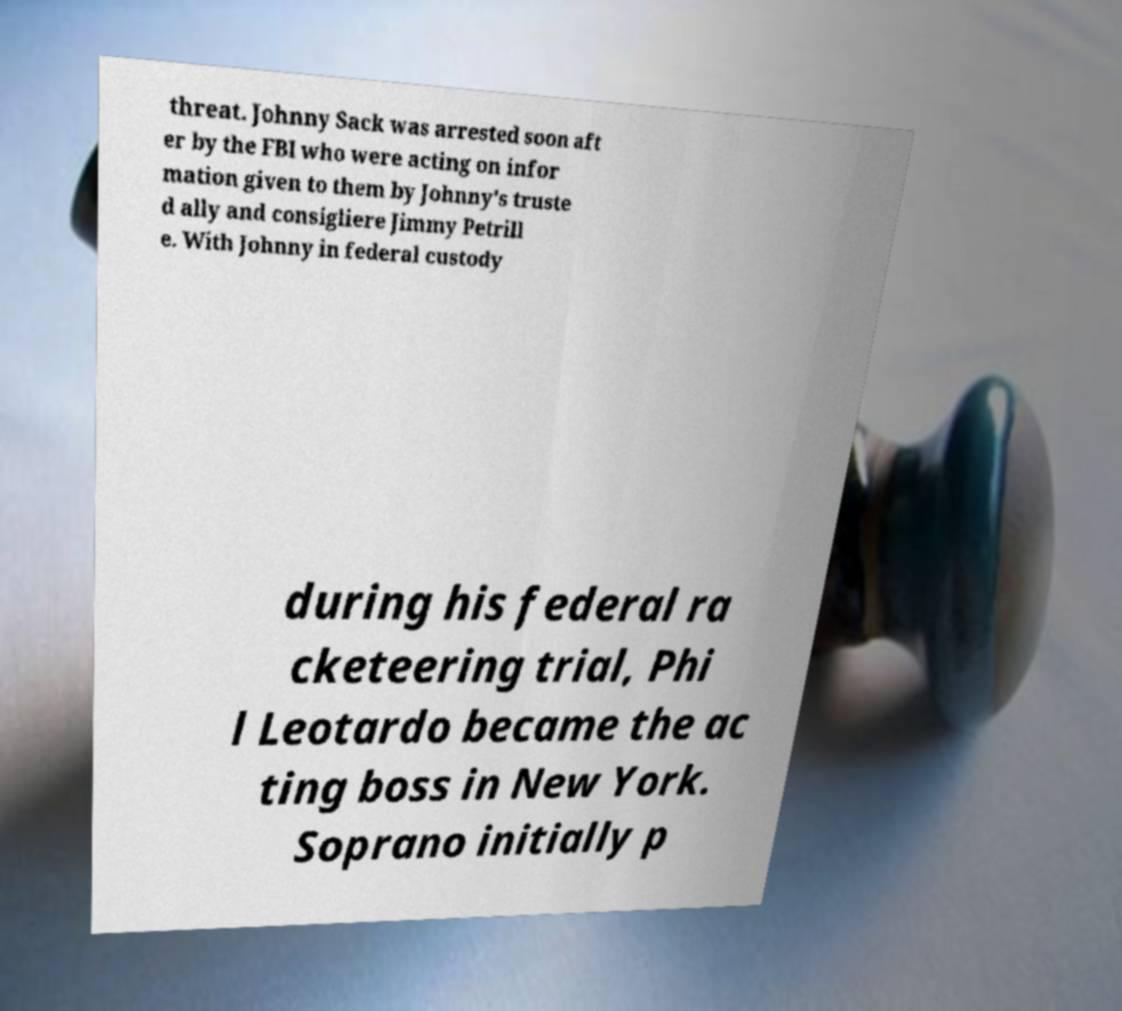I need the written content from this picture converted into text. Can you do that? threat. Johnny Sack was arrested soon aft er by the FBI who were acting on infor mation given to them by Johnny's truste d ally and consigliere Jimmy Petrill e. With Johnny in federal custody during his federal ra cketeering trial, Phi l Leotardo became the ac ting boss in New York. Soprano initially p 